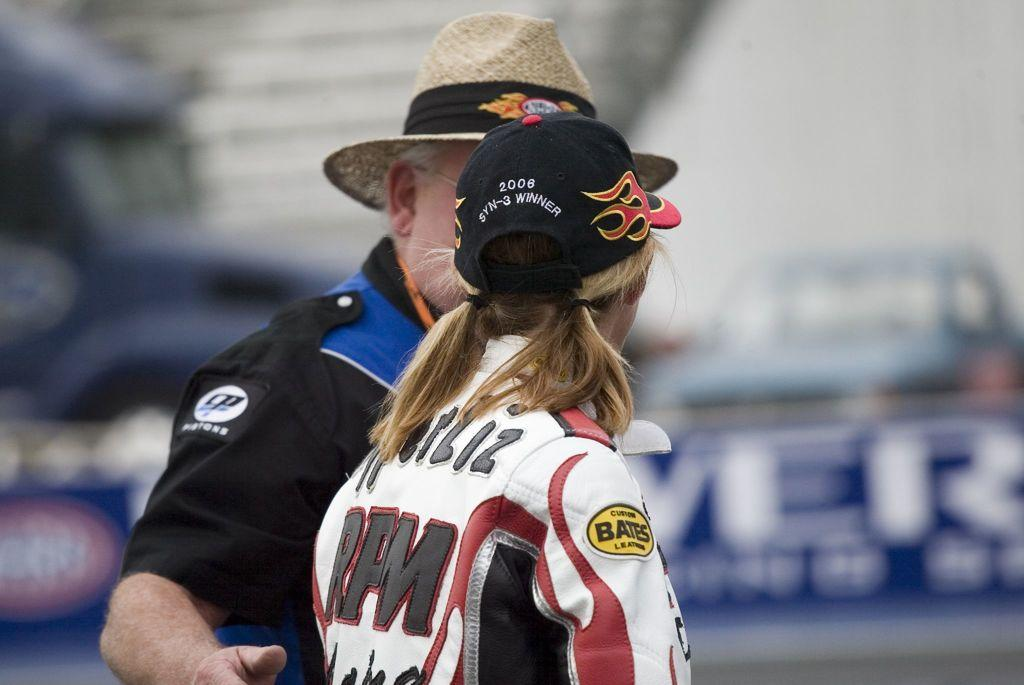<image>
Relay a brief, clear account of the picture shown. a lady with a Bates ad on her shoulder 